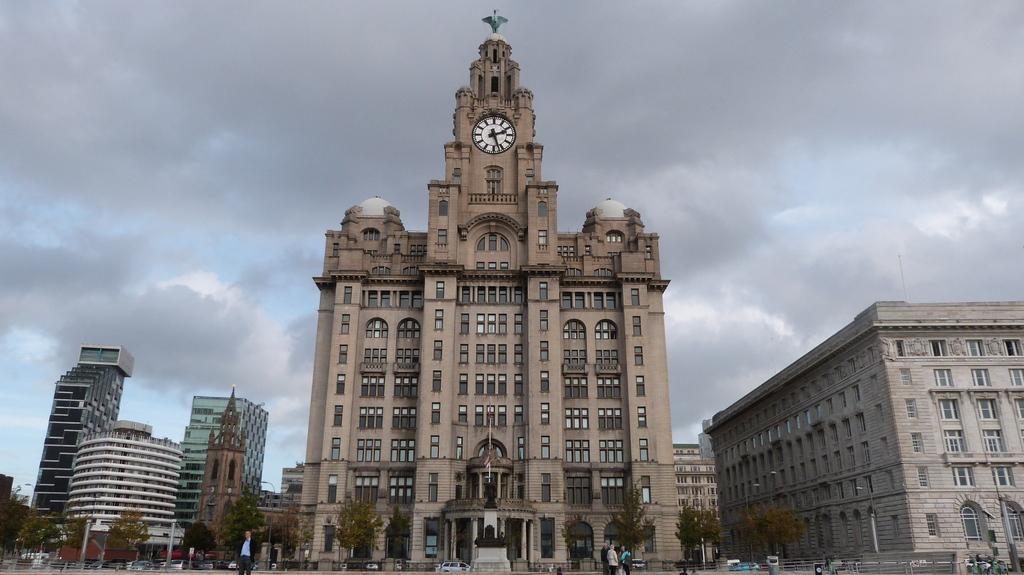How would you summarize this image in a sentence or two? In the image we can see in front there is a clock tower building and beside there are other buildings. There are people standing on the road and behind there are lot of trees. There is a cloudy sky on the top. 